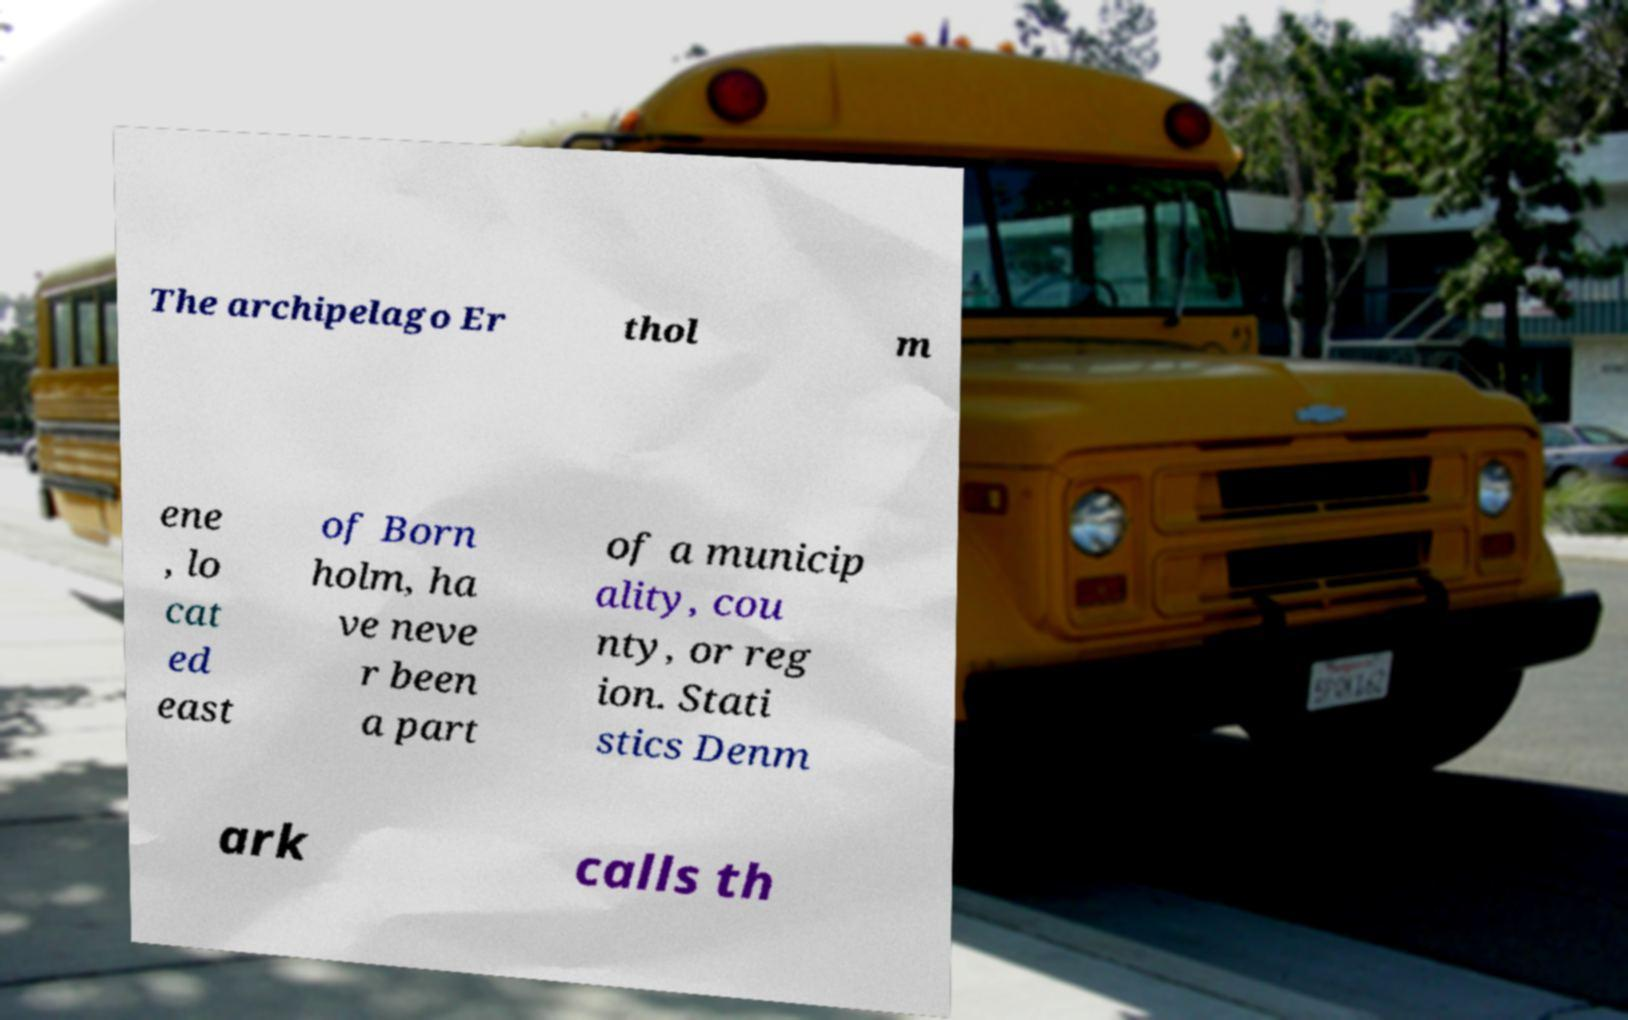Could you extract and type out the text from this image? The archipelago Er thol m ene , lo cat ed east of Born holm, ha ve neve r been a part of a municip ality, cou nty, or reg ion. Stati stics Denm ark calls th 